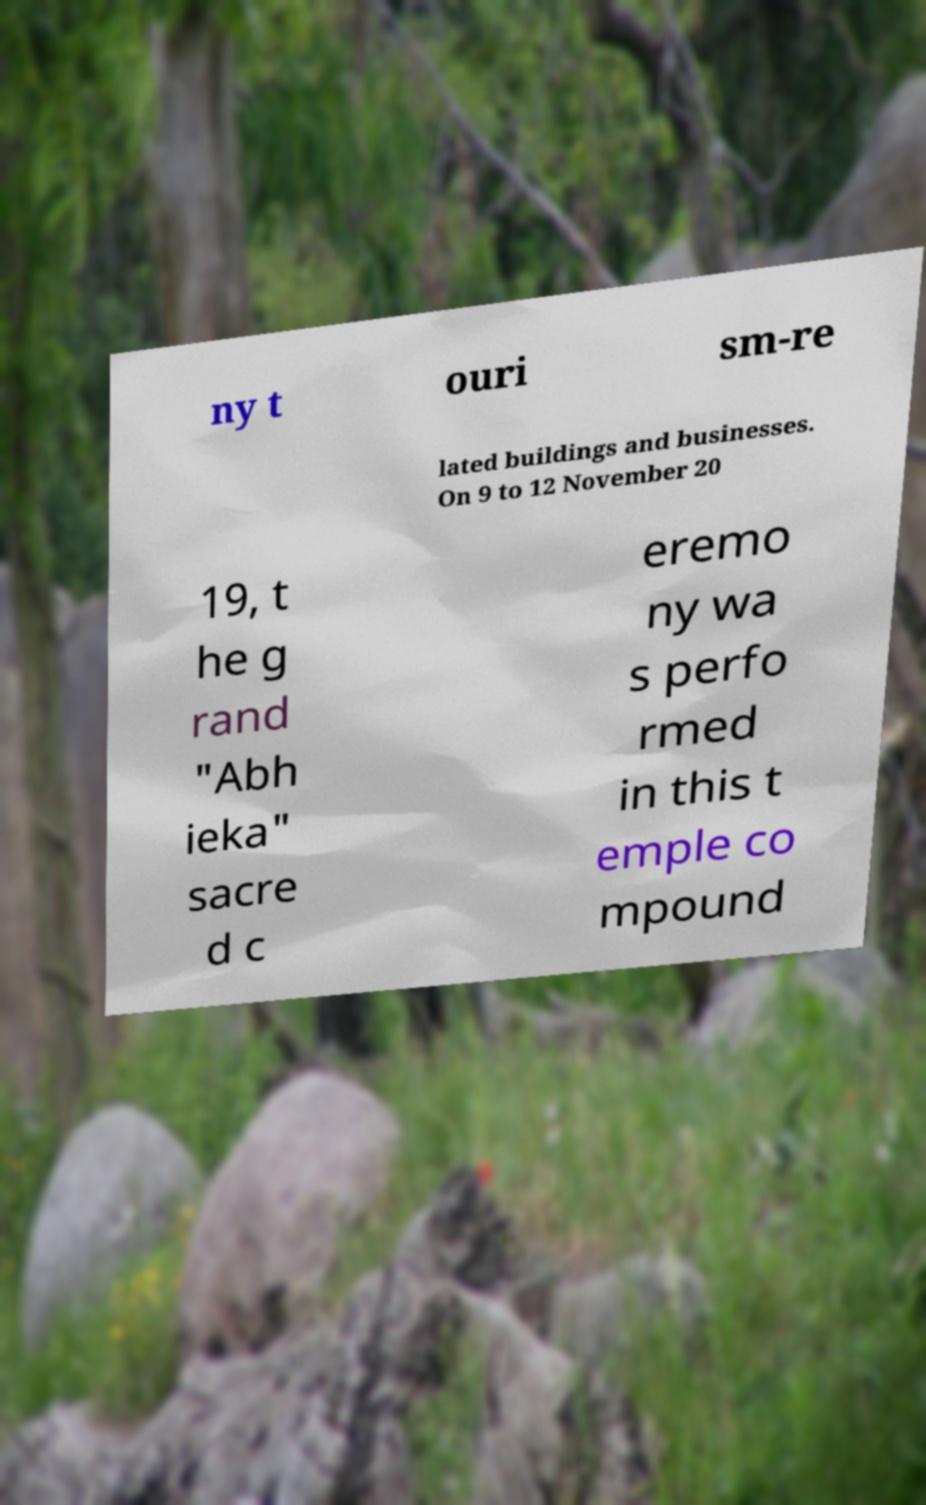Please read and relay the text visible in this image. What does it say? ny t ouri sm-re lated buildings and businesses. On 9 to 12 November 20 19, t he g rand "Abh ieka" sacre d c eremo ny wa s perfo rmed in this t emple co mpound 